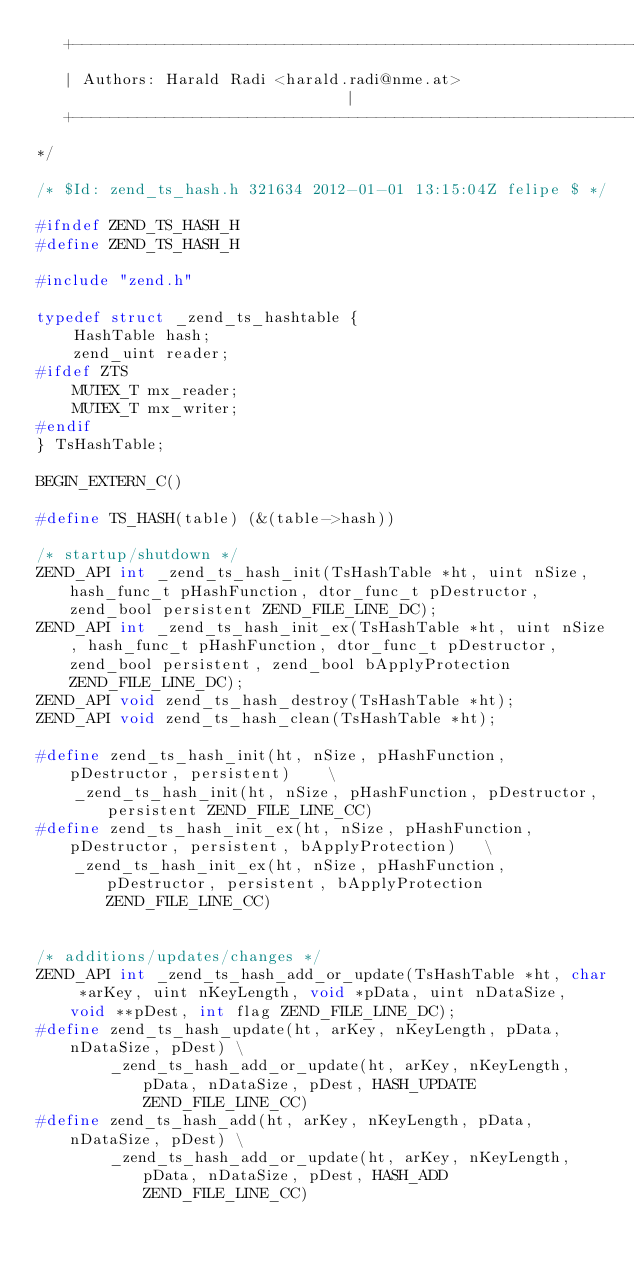<code> <loc_0><loc_0><loc_500><loc_500><_C_>   +----------------------------------------------------------------------+
   | Authors: Harald Radi <harald.radi@nme.at>                            |
   +----------------------------------------------------------------------+
*/

/* $Id: zend_ts_hash.h 321634 2012-01-01 13:15:04Z felipe $ */

#ifndef ZEND_TS_HASH_H
#define ZEND_TS_HASH_H

#include "zend.h"

typedef struct _zend_ts_hashtable {
	HashTable hash;
	zend_uint reader;
#ifdef ZTS
	MUTEX_T mx_reader;
	MUTEX_T mx_writer;
#endif
} TsHashTable;

BEGIN_EXTERN_C()

#define TS_HASH(table) (&(table->hash))

/* startup/shutdown */
ZEND_API int _zend_ts_hash_init(TsHashTable *ht, uint nSize, hash_func_t pHashFunction, dtor_func_t pDestructor, zend_bool persistent ZEND_FILE_LINE_DC);
ZEND_API int _zend_ts_hash_init_ex(TsHashTable *ht, uint nSize, hash_func_t pHashFunction, dtor_func_t pDestructor, zend_bool persistent, zend_bool bApplyProtection ZEND_FILE_LINE_DC);
ZEND_API void zend_ts_hash_destroy(TsHashTable *ht);
ZEND_API void zend_ts_hash_clean(TsHashTable *ht);

#define zend_ts_hash_init(ht, nSize, pHashFunction, pDestructor, persistent)	\
	_zend_ts_hash_init(ht, nSize, pHashFunction, pDestructor, persistent ZEND_FILE_LINE_CC)
#define zend_ts_hash_init_ex(ht, nSize, pHashFunction, pDestructor, persistent, bApplyProtection)	\
	_zend_ts_hash_init_ex(ht, nSize, pHashFunction, pDestructor, persistent, bApplyProtection ZEND_FILE_LINE_CC)


/* additions/updates/changes */
ZEND_API int _zend_ts_hash_add_or_update(TsHashTable *ht, char *arKey, uint nKeyLength, void *pData, uint nDataSize, void **pDest, int flag ZEND_FILE_LINE_DC);
#define zend_ts_hash_update(ht, arKey, nKeyLength, pData, nDataSize, pDest) \
		_zend_ts_hash_add_or_update(ht, arKey, nKeyLength, pData, nDataSize, pDest, HASH_UPDATE ZEND_FILE_LINE_CC)
#define zend_ts_hash_add(ht, arKey, nKeyLength, pData, nDataSize, pDest) \
		_zend_ts_hash_add_or_update(ht, arKey, nKeyLength, pData, nDataSize, pDest, HASH_ADD ZEND_FILE_LINE_CC)
</code> 